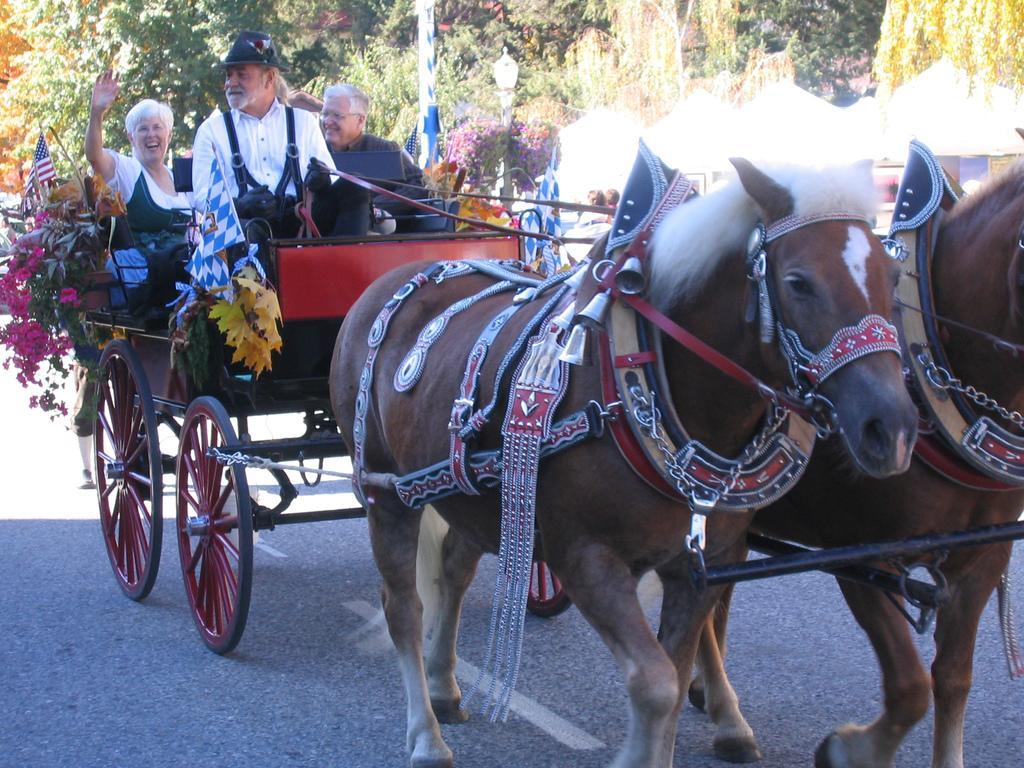Could you give a brief overview of what you see in this image? In this image i can see two horses on the road there are few belts on the horse, at the back ground i can see two man and a woman sitting on the cart, ,man wearing white shirt, at the left the man wearing black shirt at right the woman wearing white dress there are red color flowers beside a woman and a flag at the back ground i can see a tree and a pole. 